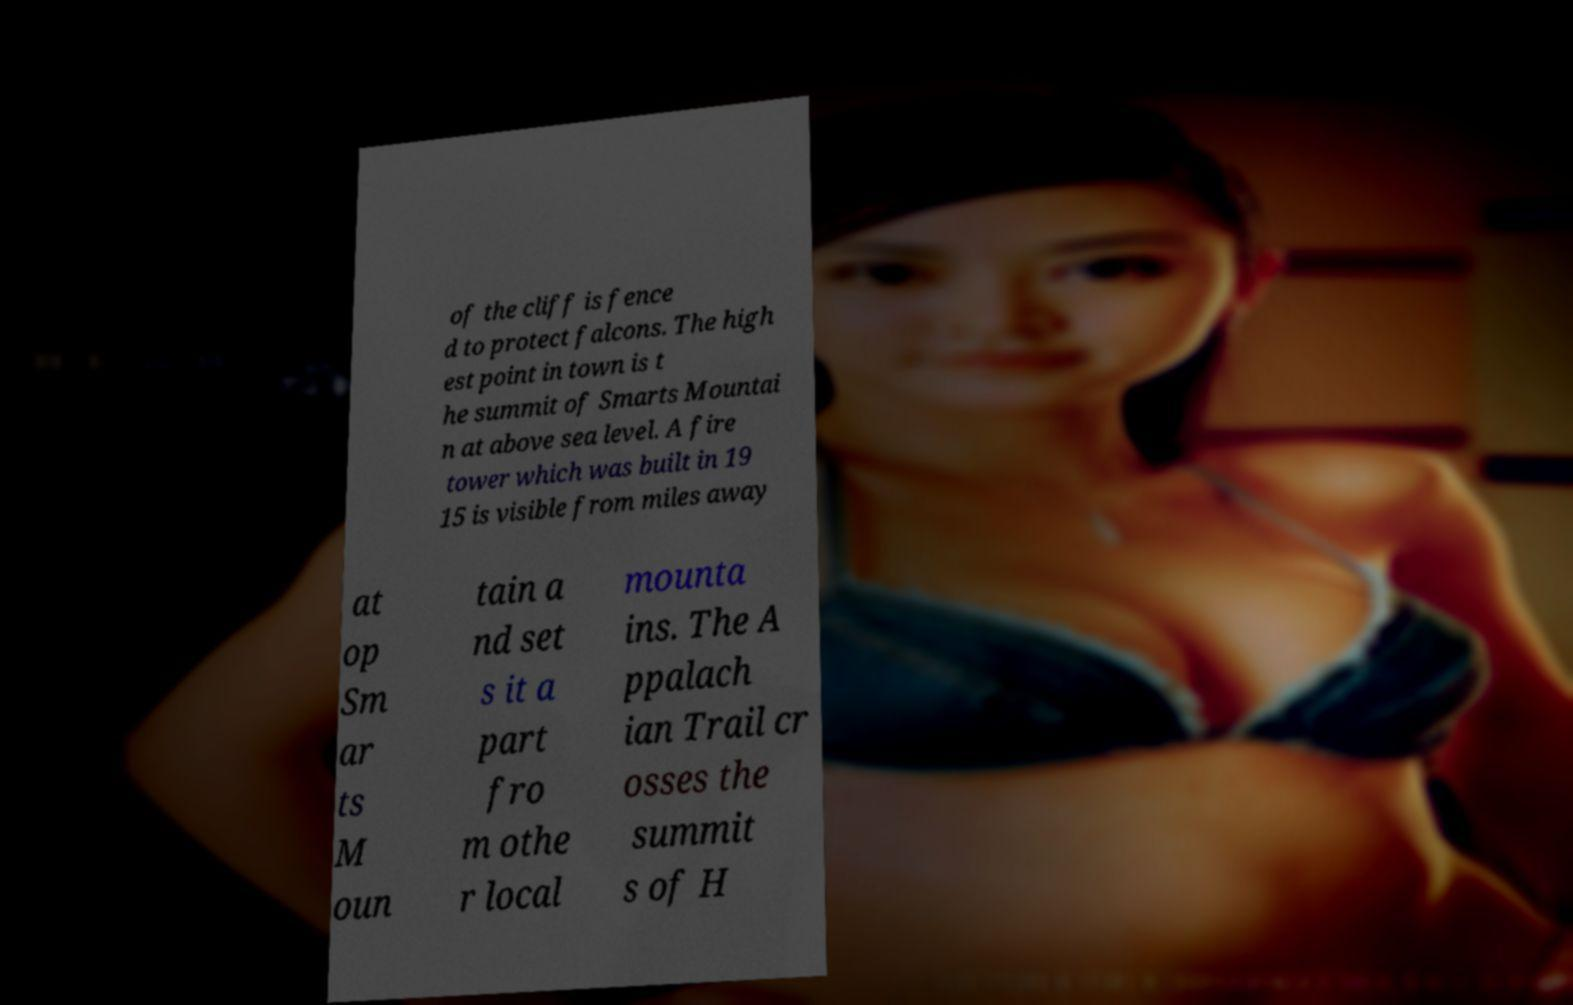There's text embedded in this image that I need extracted. Can you transcribe it verbatim? of the cliff is fence d to protect falcons. The high est point in town is t he summit of Smarts Mountai n at above sea level. A fire tower which was built in 19 15 is visible from miles away at op Sm ar ts M oun tain a nd set s it a part fro m othe r local mounta ins. The A ppalach ian Trail cr osses the summit s of H 